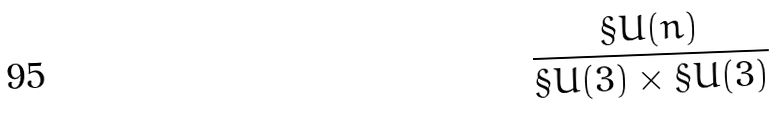Convert formula to latex. <formula><loc_0><loc_0><loc_500><loc_500>\frac { \S U ( n ) } { \S U ( 3 ) \times \S U ( 3 ) }</formula> 